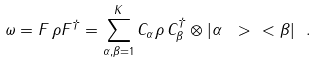<formula> <loc_0><loc_0><loc_500><loc_500>\omega = F \, \rho F ^ { \dagger } = \sum _ { \alpha , \beta = 1 } ^ { K } C _ { \alpha } \rho \, C _ { \beta } ^ { \dagger } \otimes | \alpha \ > \ < \beta | \ .</formula> 